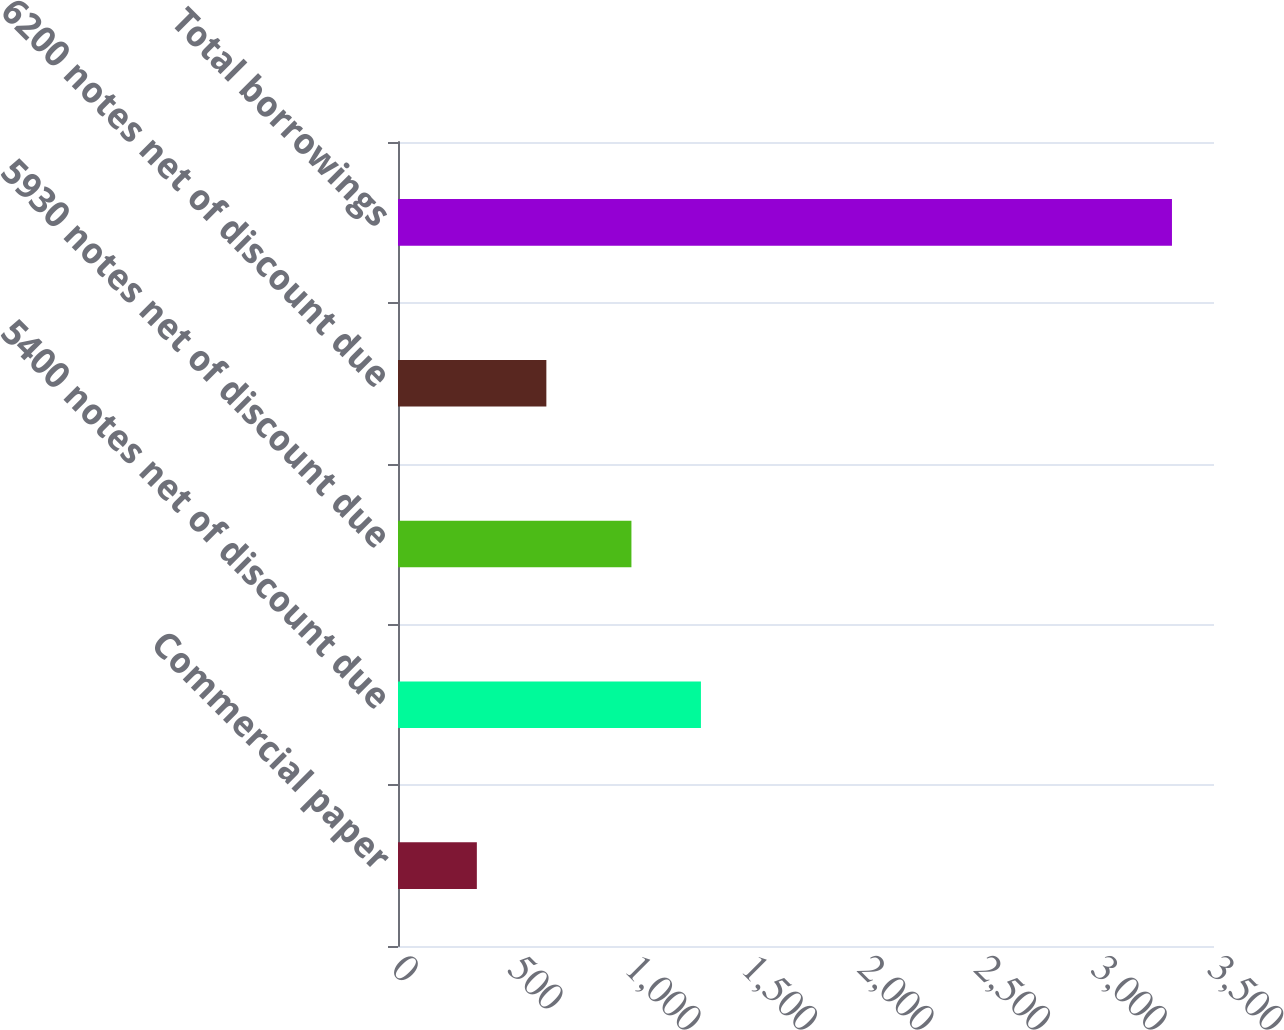Convert chart. <chart><loc_0><loc_0><loc_500><loc_500><bar_chart><fcel>Commercial paper<fcel>5400 notes net of discount due<fcel>5930 notes net of discount due<fcel>6200 notes net of discount due<fcel>Total borrowings<nl><fcel>338.2<fcel>1299.35<fcel>1001.2<fcel>636.35<fcel>3319.7<nl></chart> 